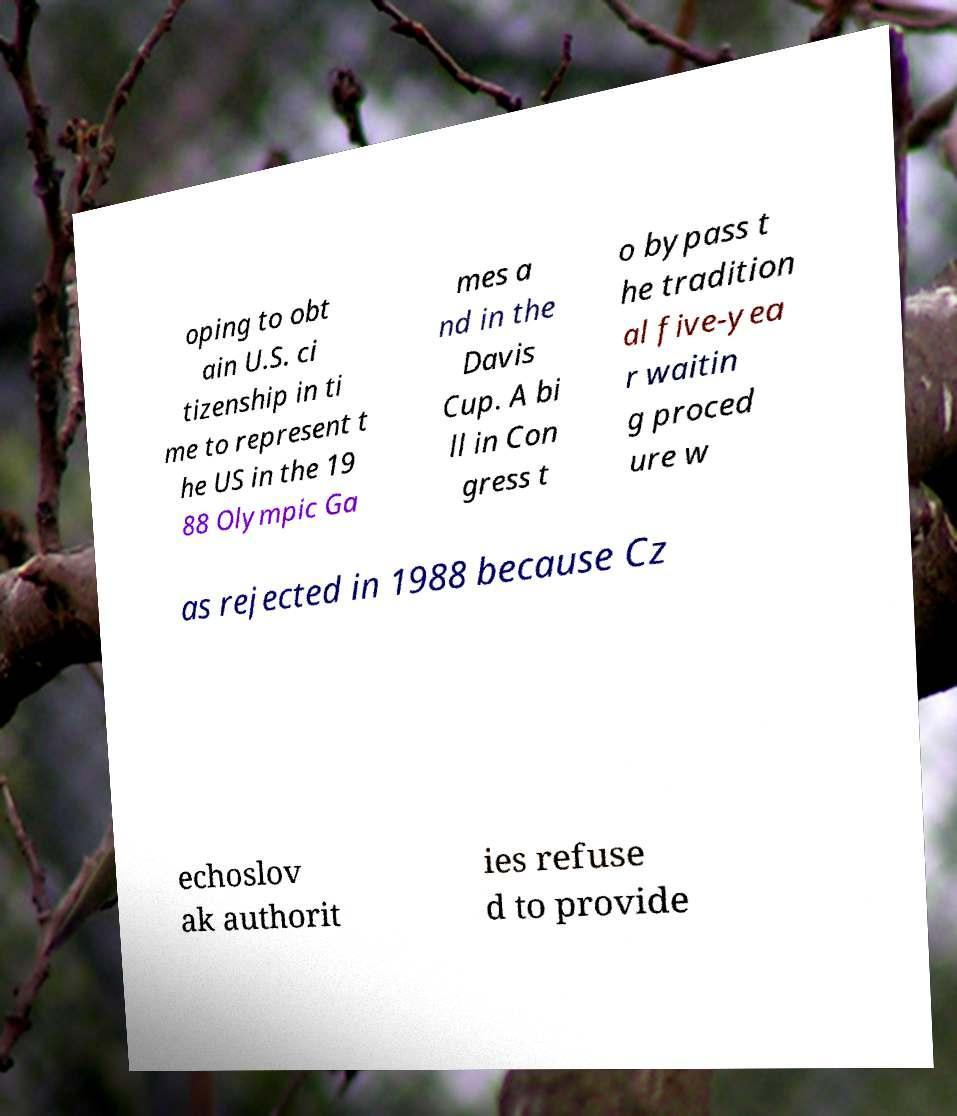What messages or text are displayed in this image? I need them in a readable, typed format. oping to obt ain U.S. ci tizenship in ti me to represent t he US in the 19 88 Olympic Ga mes a nd in the Davis Cup. A bi ll in Con gress t o bypass t he tradition al five-yea r waitin g proced ure w as rejected in 1988 because Cz echoslov ak authorit ies refuse d to provide 